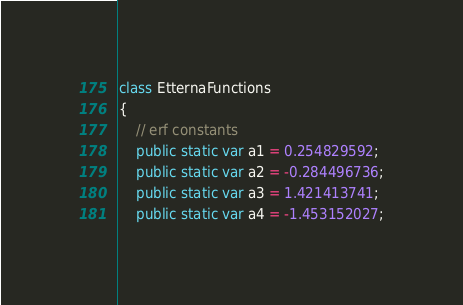<code> <loc_0><loc_0><loc_500><loc_500><_Haxe_>class EtternaFunctions
{
	// erf constants
	public static var a1 = 0.254829592;
	public static var a2 = -0.284496736;
	public static var a3 = 1.421413741;
	public static var a4 = -1.453152027;</code> 